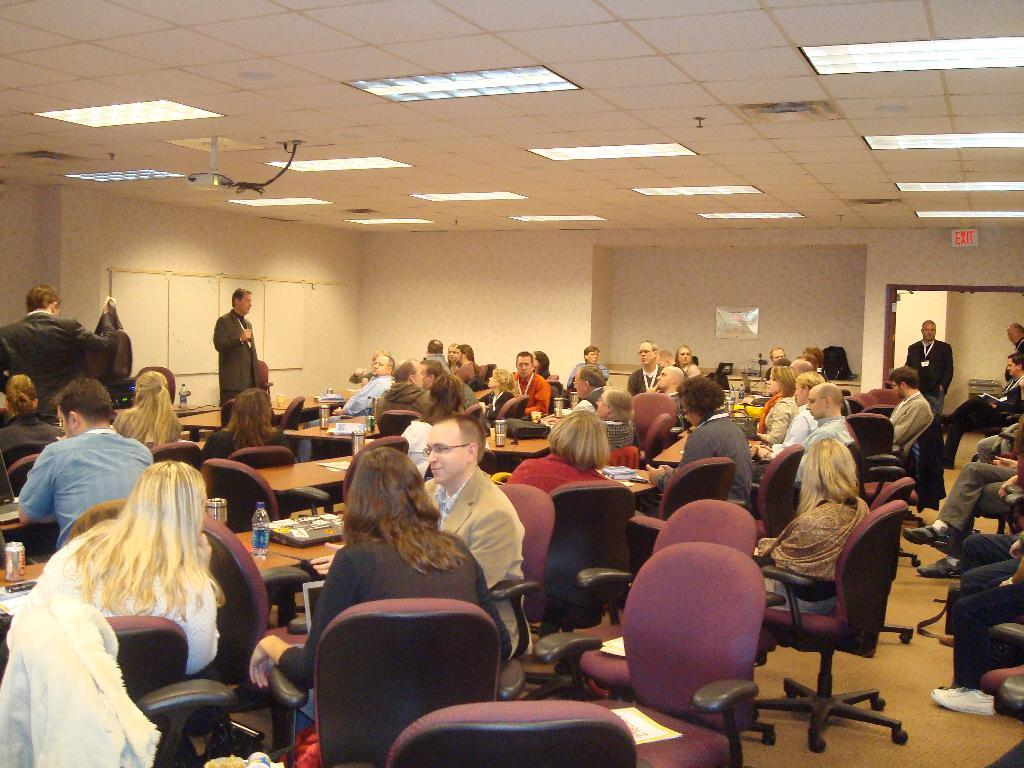What is happening in the image? There is a group of people in the image, and they are sitting in a meeting room. What are the people doing in the meeting room? The people are listening to a man's speech. What type of blood vessels can be seen in the image? There are no blood vessels present in the image; it features a group of people in a meeting room listening to a speech. 